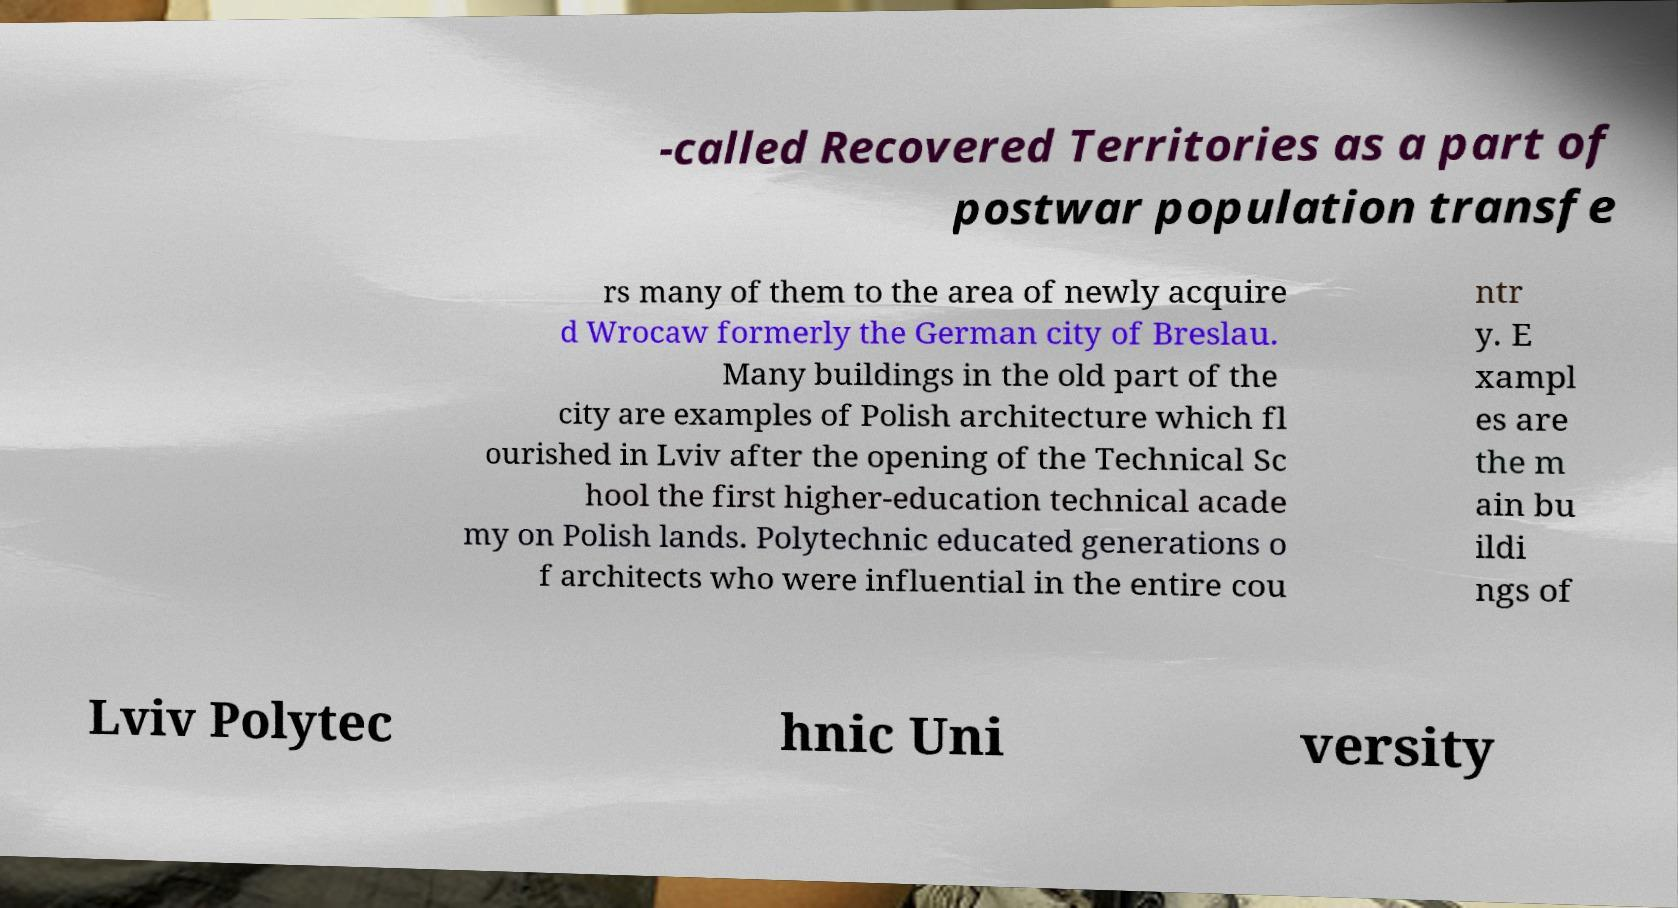Could you assist in decoding the text presented in this image and type it out clearly? -called Recovered Territories as a part of postwar population transfe rs many of them to the area of newly acquire d Wrocaw formerly the German city of Breslau. Many buildings in the old part of the city are examples of Polish architecture which fl ourished in Lviv after the opening of the Technical Sc hool the first higher-education technical acade my on Polish lands. Polytechnic educated generations o f architects who were influential in the entire cou ntr y. E xampl es are the m ain bu ildi ngs of Lviv Polytec hnic Uni versity 